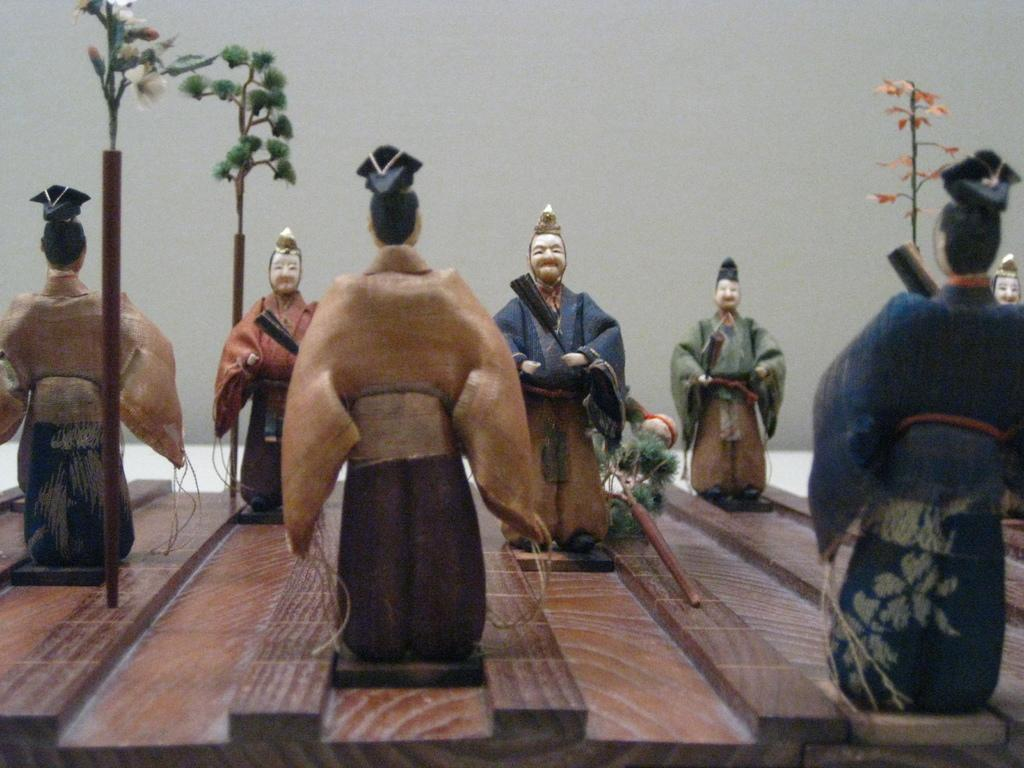What objects are placed on the table in the image? There are toys placed on the table in the image. Where is the table located in the image? The table is in the middle of the image. What can be seen in the background of the image? There is a wall visible in the background of the image. What type of lace is used to decorate the leather toys in the image? There are no toys made of leather or decorated with lace in the image. 